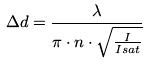Convert formula to latex. <formula><loc_0><loc_0><loc_500><loc_500>\Delta d = \frac { \lambda } { \pi \cdot n \cdot \sqrt { \frac { I } { I s a t } } }</formula> 